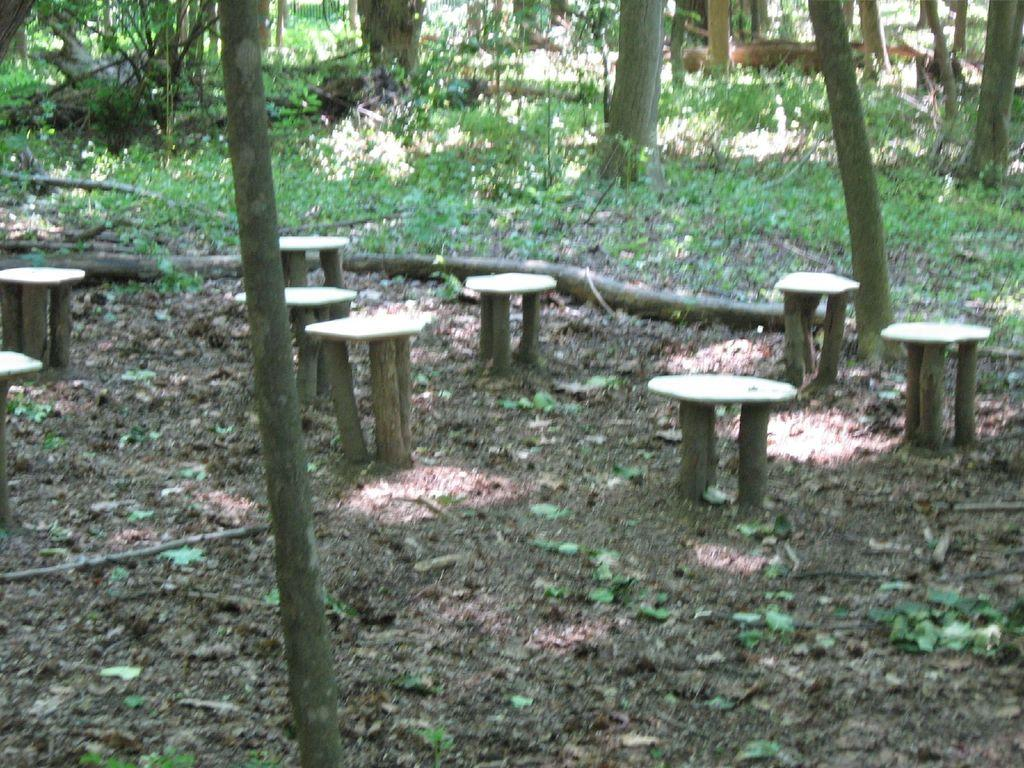What type of furniture is present in the image? There are wooden stools in the image. What natural elements can be seen in the image? There are trees, plants, grass, and soil on the floor in the image. Can you describe the flooring in the image? The flooring in the image consists of grass and soil. What type of winter sport is being played in the image? There is no winter sport or any indication of winter in the image. How does the plough help in the image? There is no plough present in the image. 